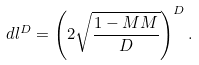Convert formula to latex. <formula><loc_0><loc_0><loc_500><loc_500>d l ^ { D } = \left ( 2 \sqrt { \frac { 1 - M M } { D } } \right ) ^ { D } .</formula> 